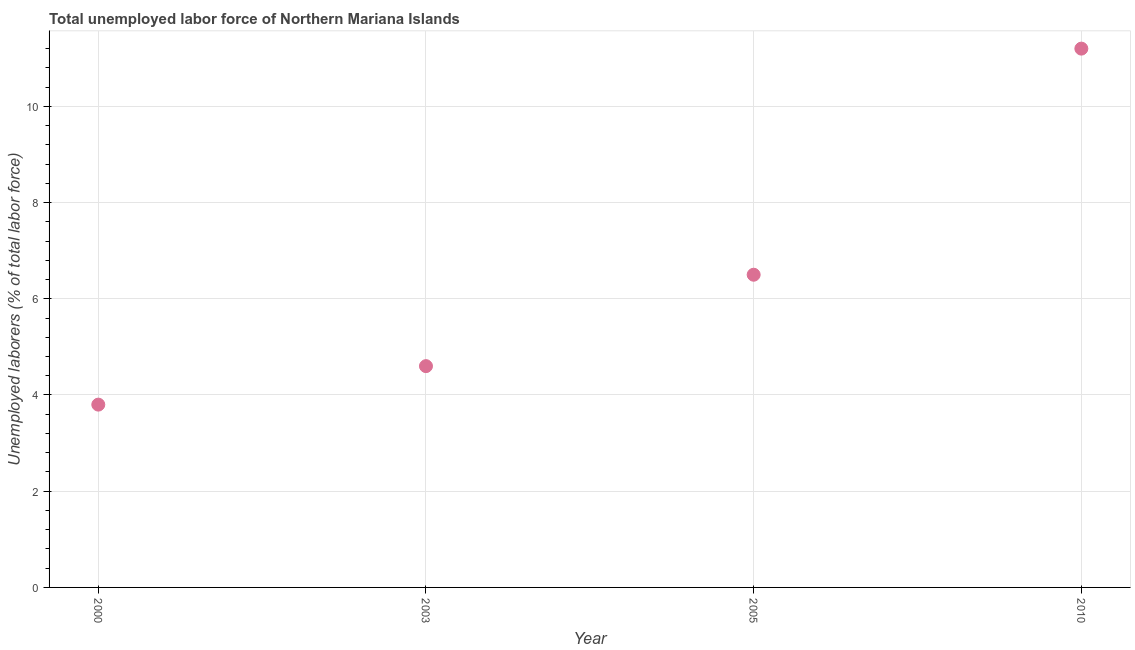What is the total unemployed labour force in 2000?
Offer a terse response. 3.8. Across all years, what is the maximum total unemployed labour force?
Give a very brief answer. 11.2. Across all years, what is the minimum total unemployed labour force?
Provide a succinct answer. 3.8. What is the sum of the total unemployed labour force?
Your answer should be compact. 26.1. What is the difference between the total unemployed labour force in 2000 and 2005?
Ensure brevity in your answer.  -2.7. What is the average total unemployed labour force per year?
Ensure brevity in your answer.  6.52. What is the median total unemployed labour force?
Provide a short and direct response. 5.55. What is the ratio of the total unemployed labour force in 2003 to that in 2005?
Offer a terse response. 0.71. What is the difference between the highest and the second highest total unemployed labour force?
Your response must be concise. 4.7. What is the difference between the highest and the lowest total unemployed labour force?
Make the answer very short. 7.4. Does the total unemployed labour force monotonically increase over the years?
Offer a very short reply. Yes. How many years are there in the graph?
Provide a succinct answer. 4. What is the difference between two consecutive major ticks on the Y-axis?
Offer a very short reply. 2. Does the graph contain any zero values?
Keep it short and to the point. No. Does the graph contain grids?
Keep it short and to the point. Yes. What is the title of the graph?
Offer a terse response. Total unemployed labor force of Northern Mariana Islands. What is the label or title of the X-axis?
Keep it short and to the point. Year. What is the label or title of the Y-axis?
Provide a succinct answer. Unemployed laborers (% of total labor force). What is the Unemployed laborers (% of total labor force) in 2000?
Make the answer very short. 3.8. What is the Unemployed laborers (% of total labor force) in 2003?
Make the answer very short. 4.6. What is the Unemployed laborers (% of total labor force) in 2005?
Offer a very short reply. 6.5. What is the Unemployed laborers (% of total labor force) in 2010?
Give a very brief answer. 11.2. What is the difference between the Unemployed laborers (% of total labor force) in 2000 and 2003?
Keep it short and to the point. -0.8. What is the difference between the Unemployed laborers (% of total labor force) in 2000 and 2005?
Make the answer very short. -2.7. What is the difference between the Unemployed laborers (% of total labor force) in 2003 and 2005?
Give a very brief answer. -1.9. What is the ratio of the Unemployed laborers (% of total labor force) in 2000 to that in 2003?
Give a very brief answer. 0.83. What is the ratio of the Unemployed laborers (% of total labor force) in 2000 to that in 2005?
Make the answer very short. 0.58. What is the ratio of the Unemployed laborers (% of total labor force) in 2000 to that in 2010?
Offer a very short reply. 0.34. What is the ratio of the Unemployed laborers (% of total labor force) in 2003 to that in 2005?
Provide a succinct answer. 0.71. What is the ratio of the Unemployed laborers (% of total labor force) in 2003 to that in 2010?
Offer a terse response. 0.41. What is the ratio of the Unemployed laborers (% of total labor force) in 2005 to that in 2010?
Ensure brevity in your answer.  0.58. 